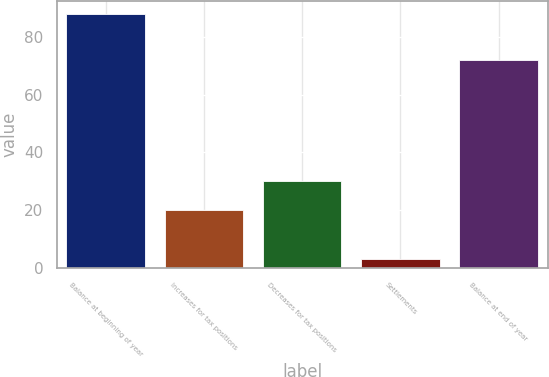Convert chart to OTSL. <chart><loc_0><loc_0><loc_500><loc_500><bar_chart><fcel>Balance at beginning of year<fcel>Increases for tax positions<fcel>Decreases for tax positions<fcel>Settlements<fcel>Balance at end of year<nl><fcel>88<fcel>20<fcel>30<fcel>3<fcel>72<nl></chart> 